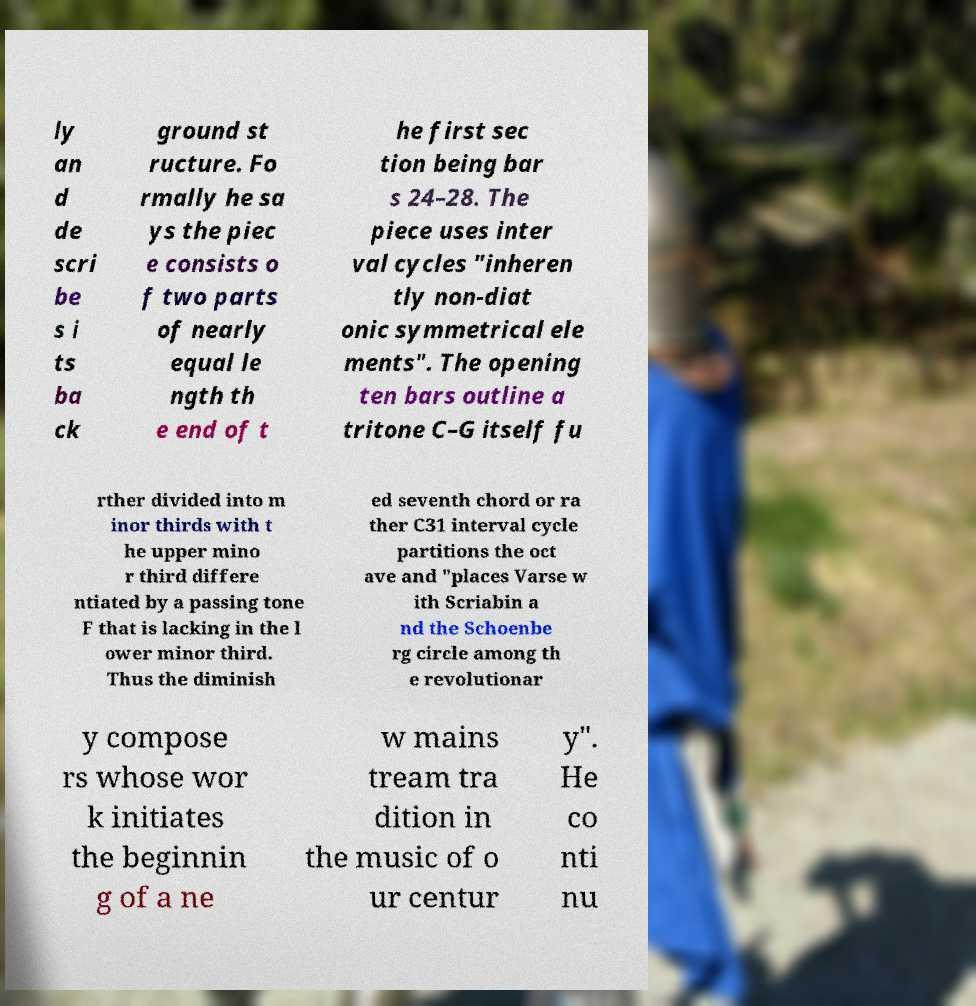Can you read and provide the text displayed in the image?This photo seems to have some interesting text. Can you extract and type it out for me? ly an d de scri be s i ts ba ck ground st ructure. Fo rmally he sa ys the piec e consists o f two parts of nearly equal le ngth th e end of t he first sec tion being bar s 24–28. The piece uses inter val cycles "inheren tly non-diat onic symmetrical ele ments". The opening ten bars outline a tritone C–G itself fu rther divided into m inor thirds with t he upper mino r third differe ntiated by a passing tone F that is lacking in the l ower minor third. Thus the diminish ed seventh chord or ra ther C31 interval cycle partitions the oct ave and "places Varse w ith Scriabin a nd the Schoenbe rg circle among th e revolutionar y compose rs whose wor k initiates the beginnin g of a ne w mains tream tra dition in the music of o ur centur y". He co nti nu 